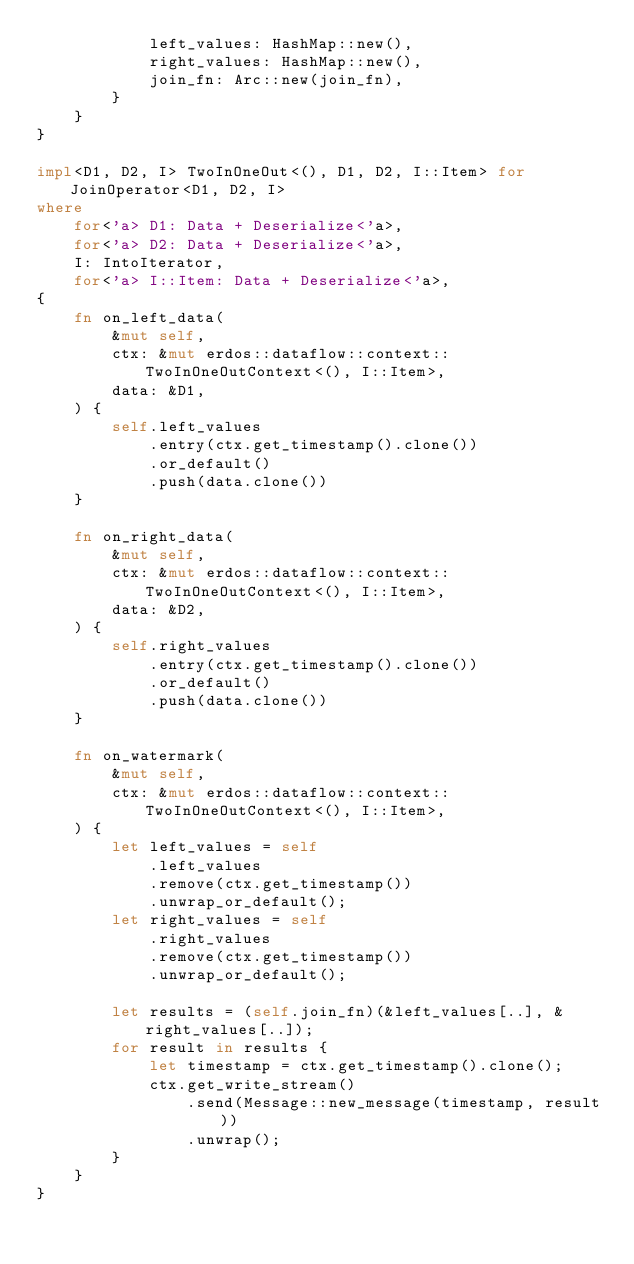<code> <loc_0><loc_0><loc_500><loc_500><_Rust_>            left_values: HashMap::new(),
            right_values: HashMap::new(),
            join_fn: Arc::new(join_fn),
        }
    }
}

impl<D1, D2, I> TwoInOneOut<(), D1, D2, I::Item> for JoinOperator<D1, D2, I>
where
    for<'a> D1: Data + Deserialize<'a>,
    for<'a> D2: Data + Deserialize<'a>,
    I: IntoIterator,
    for<'a> I::Item: Data + Deserialize<'a>,
{
    fn on_left_data(
        &mut self,
        ctx: &mut erdos::dataflow::context::TwoInOneOutContext<(), I::Item>,
        data: &D1,
    ) {
        self.left_values
            .entry(ctx.get_timestamp().clone())
            .or_default()
            .push(data.clone())
    }

    fn on_right_data(
        &mut self,
        ctx: &mut erdos::dataflow::context::TwoInOneOutContext<(), I::Item>,
        data: &D2,
    ) {
        self.right_values
            .entry(ctx.get_timestamp().clone())
            .or_default()
            .push(data.clone())
    }

    fn on_watermark(
        &mut self,
        ctx: &mut erdos::dataflow::context::TwoInOneOutContext<(), I::Item>,
    ) {
        let left_values = self
            .left_values
            .remove(ctx.get_timestamp())
            .unwrap_or_default();
        let right_values = self
            .right_values
            .remove(ctx.get_timestamp())
            .unwrap_or_default();

        let results = (self.join_fn)(&left_values[..], &right_values[..]);
        for result in results {
            let timestamp = ctx.get_timestamp().clone();
            ctx.get_write_stream()
                .send(Message::new_message(timestamp, result))
                .unwrap();
        }
    }
}
</code> 